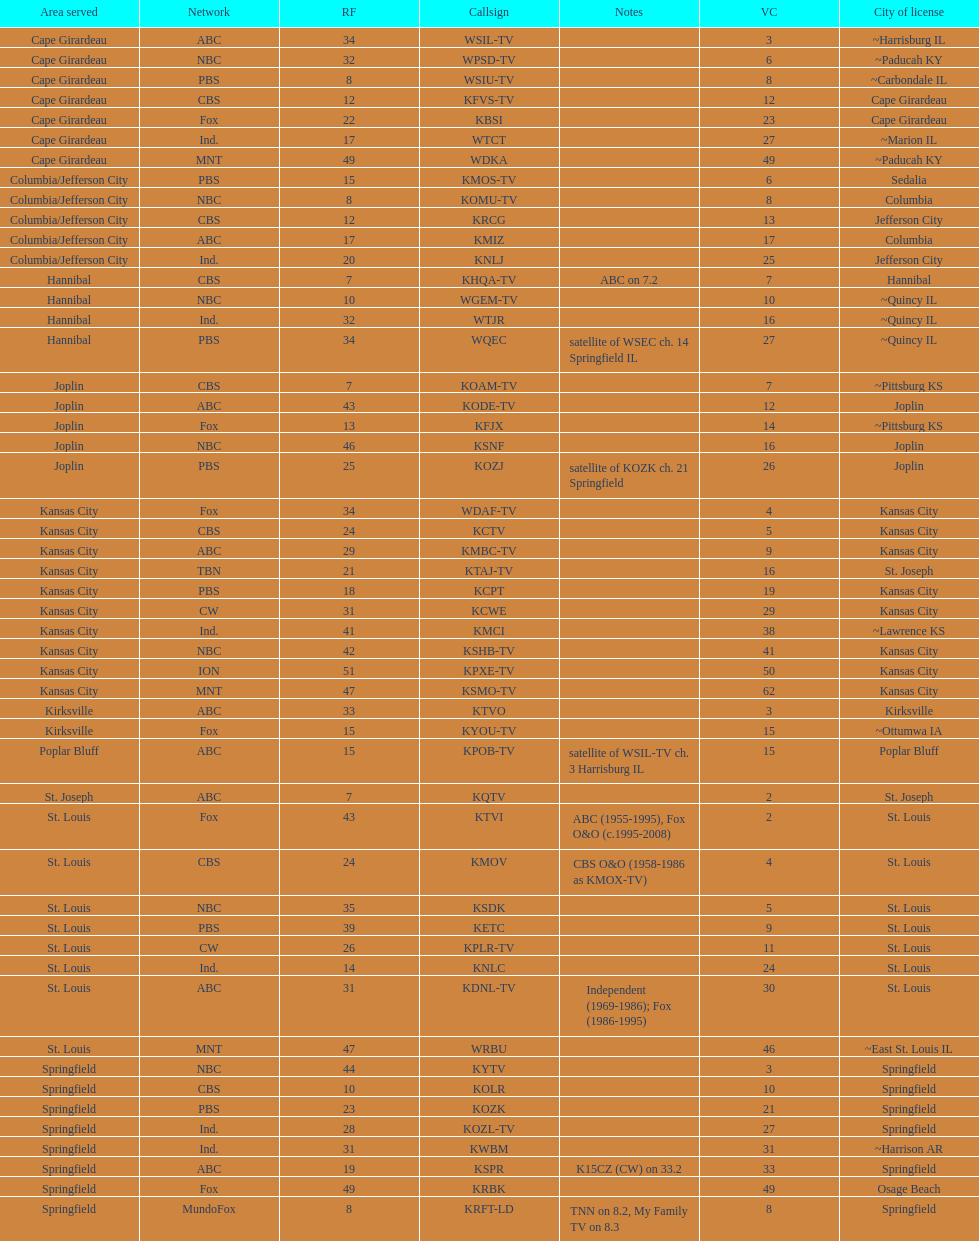Would you be able to parse every entry in this table? {'header': ['Area served', 'Network', 'RF', 'Callsign', 'Notes', 'VC', 'City of license'], 'rows': [['Cape Girardeau', 'ABC', '34', 'WSIL-TV', '', '3', '~Harrisburg IL'], ['Cape Girardeau', 'NBC', '32', 'WPSD-TV', '', '6', '~Paducah KY'], ['Cape Girardeau', 'PBS', '8', 'WSIU-TV', '', '8', '~Carbondale IL'], ['Cape Girardeau', 'CBS', '12', 'KFVS-TV', '', '12', 'Cape Girardeau'], ['Cape Girardeau', 'Fox', '22', 'KBSI', '', '23', 'Cape Girardeau'], ['Cape Girardeau', 'Ind.', '17', 'WTCT', '', '27', '~Marion IL'], ['Cape Girardeau', 'MNT', '49', 'WDKA', '', '49', '~Paducah KY'], ['Columbia/Jefferson City', 'PBS', '15', 'KMOS-TV', '', '6', 'Sedalia'], ['Columbia/Jefferson City', 'NBC', '8', 'KOMU-TV', '', '8', 'Columbia'], ['Columbia/Jefferson City', 'CBS', '12', 'KRCG', '', '13', 'Jefferson City'], ['Columbia/Jefferson City', 'ABC', '17', 'KMIZ', '', '17', 'Columbia'], ['Columbia/Jefferson City', 'Ind.', '20', 'KNLJ', '', '25', 'Jefferson City'], ['Hannibal', 'CBS', '7', 'KHQA-TV', 'ABC on 7.2', '7', 'Hannibal'], ['Hannibal', 'NBC', '10', 'WGEM-TV', '', '10', '~Quincy IL'], ['Hannibal', 'Ind.', '32', 'WTJR', '', '16', '~Quincy IL'], ['Hannibal', 'PBS', '34', 'WQEC', 'satellite of WSEC ch. 14 Springfield IL', '27', '~Quincy IL'], ['Joplin', 'CBS', '7', 'KOAM-TV', '', '7', '~Pittsburg KS'], ['Joplin', 'ABC', '43', 'KODE-TV', '', '12', 'Joplin'], ['Joplin', 'Fox', '13', 'KFJX', '', '14', '~Pittsburg KS'], ['Joplin', 'NBC', '46', 'KSNF', '', '16', 'Joplin'], ['Joplin', 'PBS', '25', 'KOZJ', 'satellite of KOZK ch. 21 Springfield', '26', 'Joplin'], ['Kansas City', 'Fox', '34', 'WDAF-TV', '', '4', 'Kansas City'], ['Kansas City', 'CBS', '24', 'KCTV', '', '5', 'Kansas City'], ['Kansas City', 'ABC', '29', 'KMBC-TV', '', '9', 'Kansas City'], ['Kansas City', 'TBN', '21', 'KTAJ-TV', '', '16', 'St. Joseph'], ['Kansas City', 'PBS', '18', 'KCPT', '', '19', 'Kansas City'], ['Kansas City', 'CW', '31', 'KCWE', '', '29', 'Kansas City'], ['Kansas City', 'Ind.', '41', 'KMCI', '', '38', '~Lawrence KS'], ['Kansas City', 'NBC', '42', 'KSHB-TV', '', '41', 'Kansas City'], ['Kansas City', 'ION', '51', 'KPXE-TV', '', '50', 'Kansas City'], ['Kansas City', 'MNT', '47', 'KSMO-TV', '', '62', 'Kansas City'], ['Kirksville', 'ABC', '33', 'KTVO', '', '3', 'Kirksville'], ['Kirksville', 'Fox', '15', 'KYOU-TV', '', '15', '~Ottumwa IA'], ['Poplar Bluff', 'ABC', '15', 'KPOB-TV', 'satellite of WSIL-TV ch. 3 Harrisburg IL', '15', 'Poplar Bluff'], ['St. Joseph', 'ABC', '7', 'KQTV', '', '2', 'St. Joseph'], ['St. Louis', 'Fox', '43', 'KTVI', 'ABC (1955-1995), Fox O&O (c.1995-2008)', '2', 'St. Louis'], ['St. Louis', 'CBS', '24', 'KMOV', 'CBS O&O (1958-1986 as KMOX-TV)', '4', 'St. Louis'], ['St. Louis', 'NBC', '35', 'KSDK', '', '5', 'St. Louis'], ['St. Louis', 'PBS', '39', 'KETC', '', '9', 'St. Louis'], ['St. Louis', 'CW', '26', 'KPLR-TV', '', '11', 'St. Louis'], ['St. Louis', 'Ind.', '14', 'KNLC', '', '24', 'St. Louis'], ['St. Louis', 'ABC', '31', 'KDNL-TV', 'Independent (1969-1986); Fox (1986-1995)', '30', 'St. Louis'], ['St. Louis', 'MNT', '47', 'WRBU', '', '46', '~East St. Louis IL'], ['Springfield', 'NBC', '44', 'KYTV', '', '3', 'Springfield'], ['Springfield', 'CBS', '10', 'KOLR', '', '10', 'Springfield'], ['Springfield', 'PBS', '23', 'KOZK', '', '21', 'Springfield'], ['Springfield', 'Ind.', '28', 'KOZL-TV', '', '27', 'Springfield'], ['Springfield', 'Ind.', '31', 'KWBM', '', '31', '~Harrison AR'], ['Springfield', 'ABC', '19', 'KSPR', 'K15CZ (CW) on 33.2', '33', 'Springfield'], ['Springfield', 'Fox', '49', 'KRBK', '', '49', 'Osage Beach'], ['Springfield', 'MundoFox', '8', 'KRFT-LD', 'TNN on 8.2, My Family TV on 8.3', '8', 'Springfield']]} What is the total number of stations serving the the cape girardeau area? 7. 